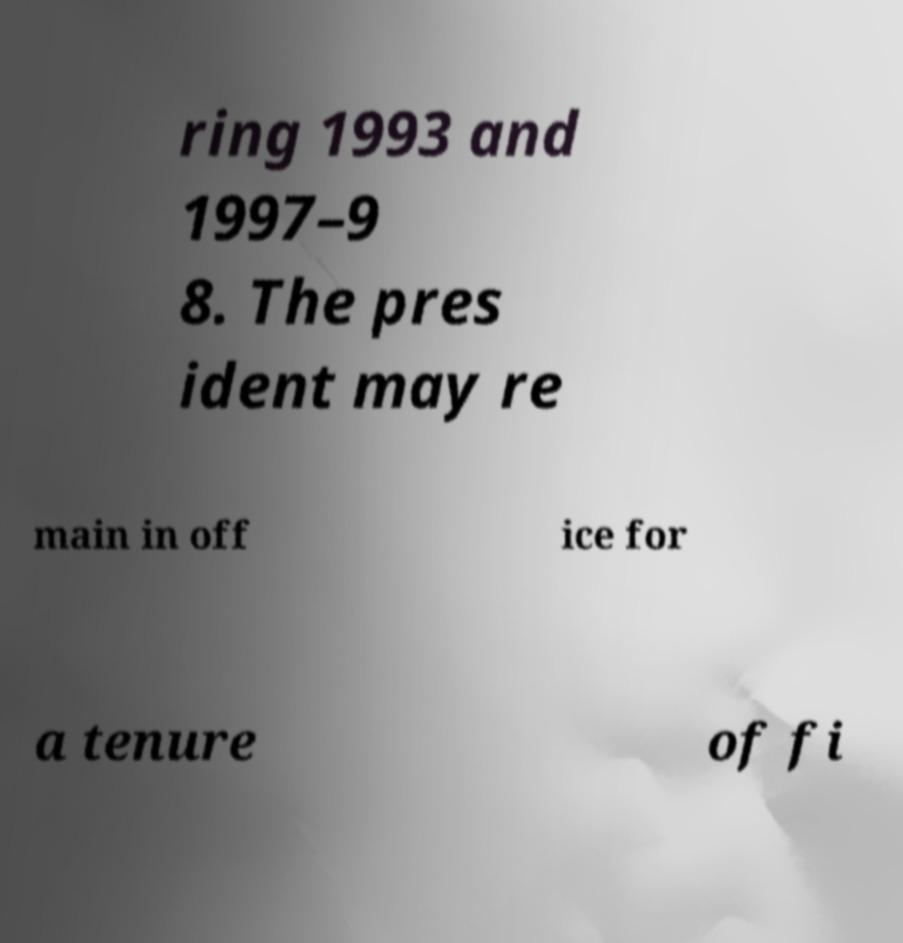Can you read and provide the text displayed in the image?This photo seems to have some interesting text. Can you extract and type it out for me? ring 1993 and 1997–9 8. The pres ident may re main in off ice for a tenure of fi 